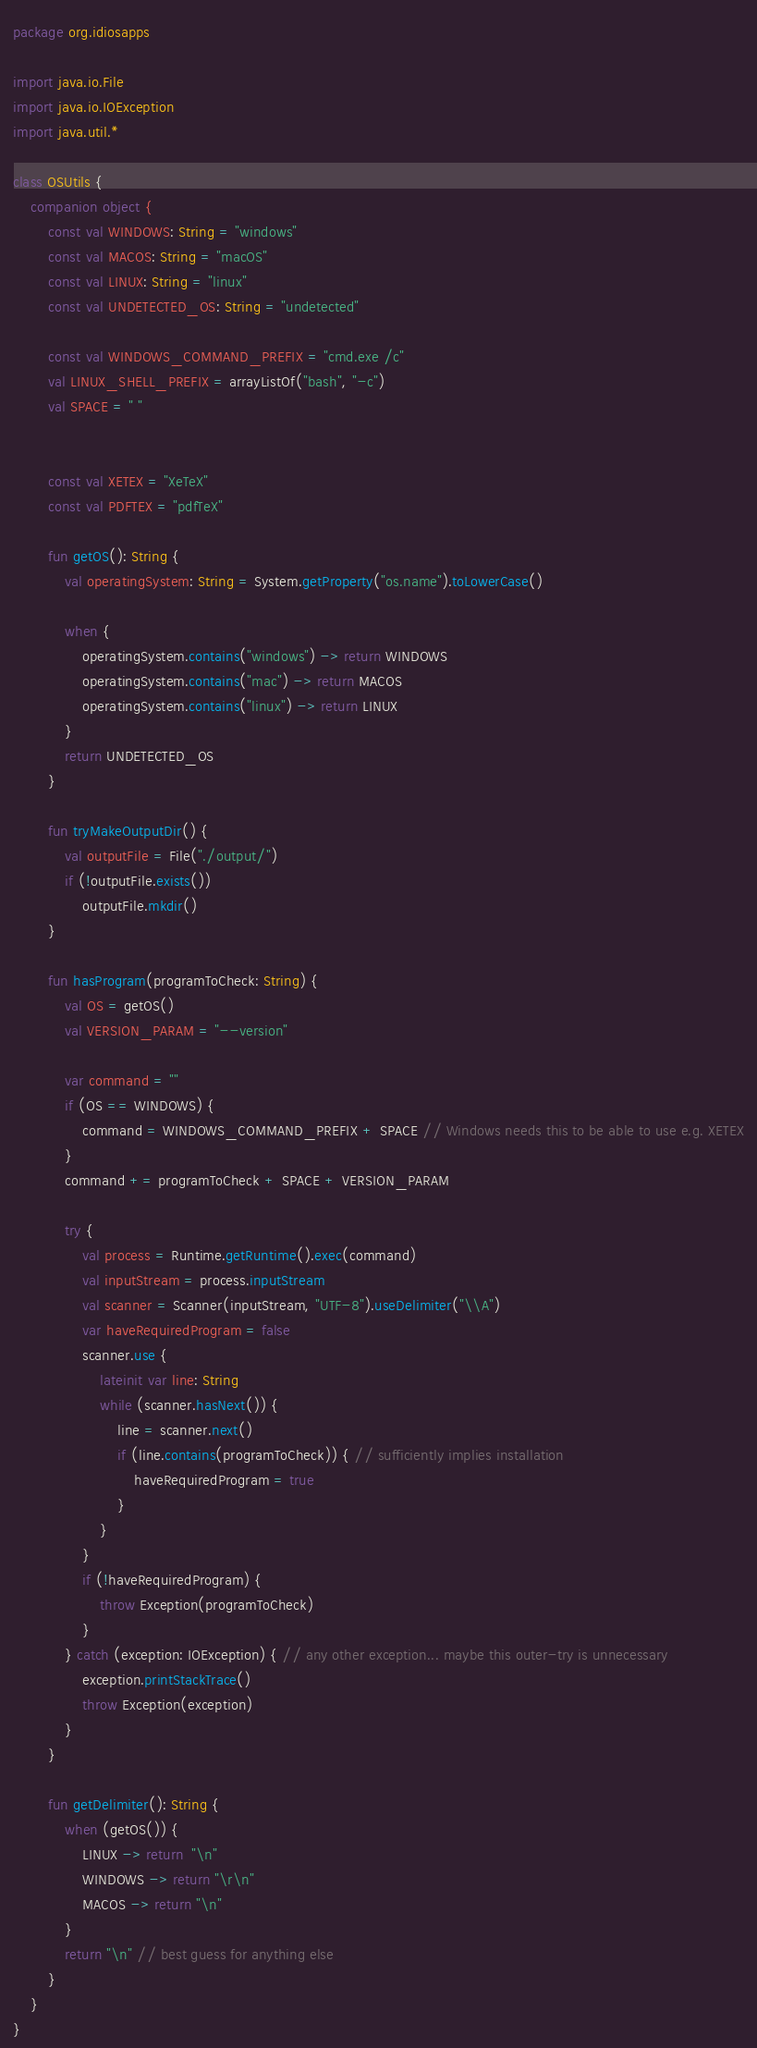<code> <loc_0><loc_0><loc_500><loc_500><_Kotlin_>package org.idiosapps

import java.io.File
import java.io.IOException
import java.util.*

class OSUtils {
    companion object {
        const val WINDOWS: String = "windows"
        const val MACOS: String = "macOS"
        const val LINUX: String = "linux"
        const val UNDETECTED_OS: String = "undetected"

        const val WINDOWS_COMMAND_PREFIX = "cmd.exe /c"
        val LINUX_SHELL_PREFIX = arrayListOf("bash", "-c")
        val SPACE = " "


        const val XETEX = "XeTeX"
        const val PDFTEX = "pdfTeX"

        fun getOS(): String {
            val operatingSystem: String = System.getProperty("os.name").toLowerCase()

            when {
                operatingSystem.contains("windows") -> return WINDOWS
                operatingSystem.contains("mac") -> return MACOS
                operatingSystem.contains("linux") -> return LINUX
            }
            return UNDETECTED_OS
        }

        fun tryMakeOutputDir() {
            val outputFile = File("./output/")
            if (!outputFile.exists())
                outputFile.mkdir()
        }

        fun hasProgram(programToCheck: String) {
            val OS = getOS()
            val VERSION_PARAM = "--version"

            var command = ""
            if (OS == WINDOWS) {
                command = WINDOWS_COMMAND_PREFIX + SPACE // Windows needs this to be able to use e.g. XETEX
            }
            command += programToCheck + SPACE + VERSION_PARAM

            try {
                val process = Runtime.getRuntime().exec(command)
                val inputStream = process.inputStream
                val scanner = Scanner(inputStream, "UTF-8").useDelimiter("\\A")
                var haveRequiredProgram = false
                scanner.use {
                    lateinit var line: String
                    while (scanner.hasNext()) {
                        line = scanner.next()
                        if (line.contains(programToCheck)) { // sufficiently implies installation
                            haveRequiredProgram = true
                        }
                    }
                }
                if (!haveRequiredProgram) {
                    throw Exception(programToCheck)
                }
            } catch (exception: IOException) { // any other exception... maybe this outer-try is unnecessary
                exception.printStackTrace()
                throw Exception(exception)
            }
        }

        fun getDelimiter(): String {
            when (getOS()) {
                LINUX -> return  "\n"
                WINDOWS -> return "\r\n"
                MACOS -> return "\n"
            }
            return "\n" // best guess for anything else
        }
    }
}</code> 